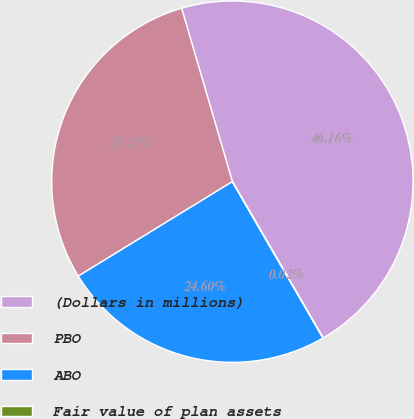<chart> <loc_0><loc_0><loc_500><loc_500><pie_chart><fcel>(Dollars in millions)<fcel>PBO<fcel>ABO<fcel>Fair value of plan assets<nl><fcel>46.16%<fcel>29.22%<fcel>24.6%<fcel>0.02%<nl></chart> 